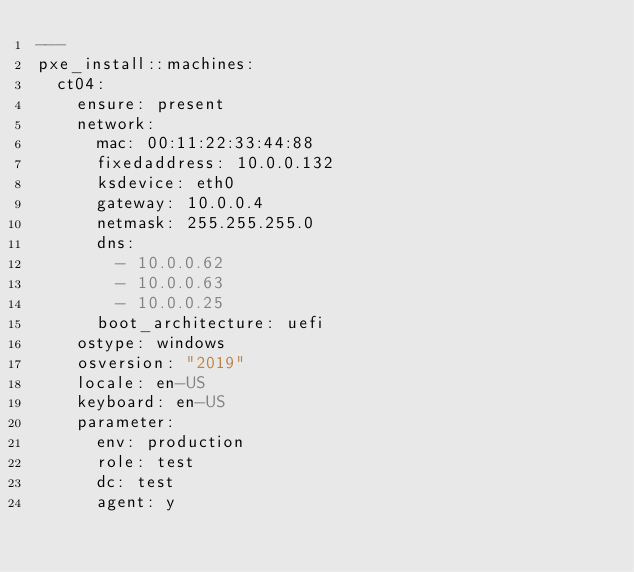Convert code to text. <code><loc_0><loc_0><loc_500><loc_500><_YAML_>---
pxe_install::machines:
  ct04:
    ensure: present
    network:
      mac: 00:11:22:33:44:88
      fixedaddress: 10.0.0.132
      ksdevice: eth0
      gateway: 10.0.0.4
      netmask: 255.255.255.0
      dns:
        - 10.0.0.62
        - 10.0.0.63
        - 10.0.0.25
      boot_architecture: uefi
    ostype: windows
    osversion: "2019"
    locale: en-US
    keyboard: en-US
    parameter:
      env: production
      role: test
      dc: test
      agent: y
</code> 